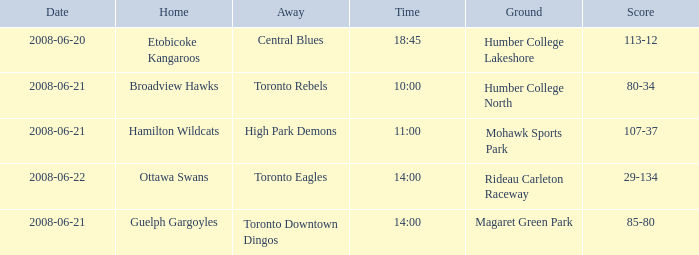What is the Date with a Home that is hamilton wildcats? 2008-06-21. 